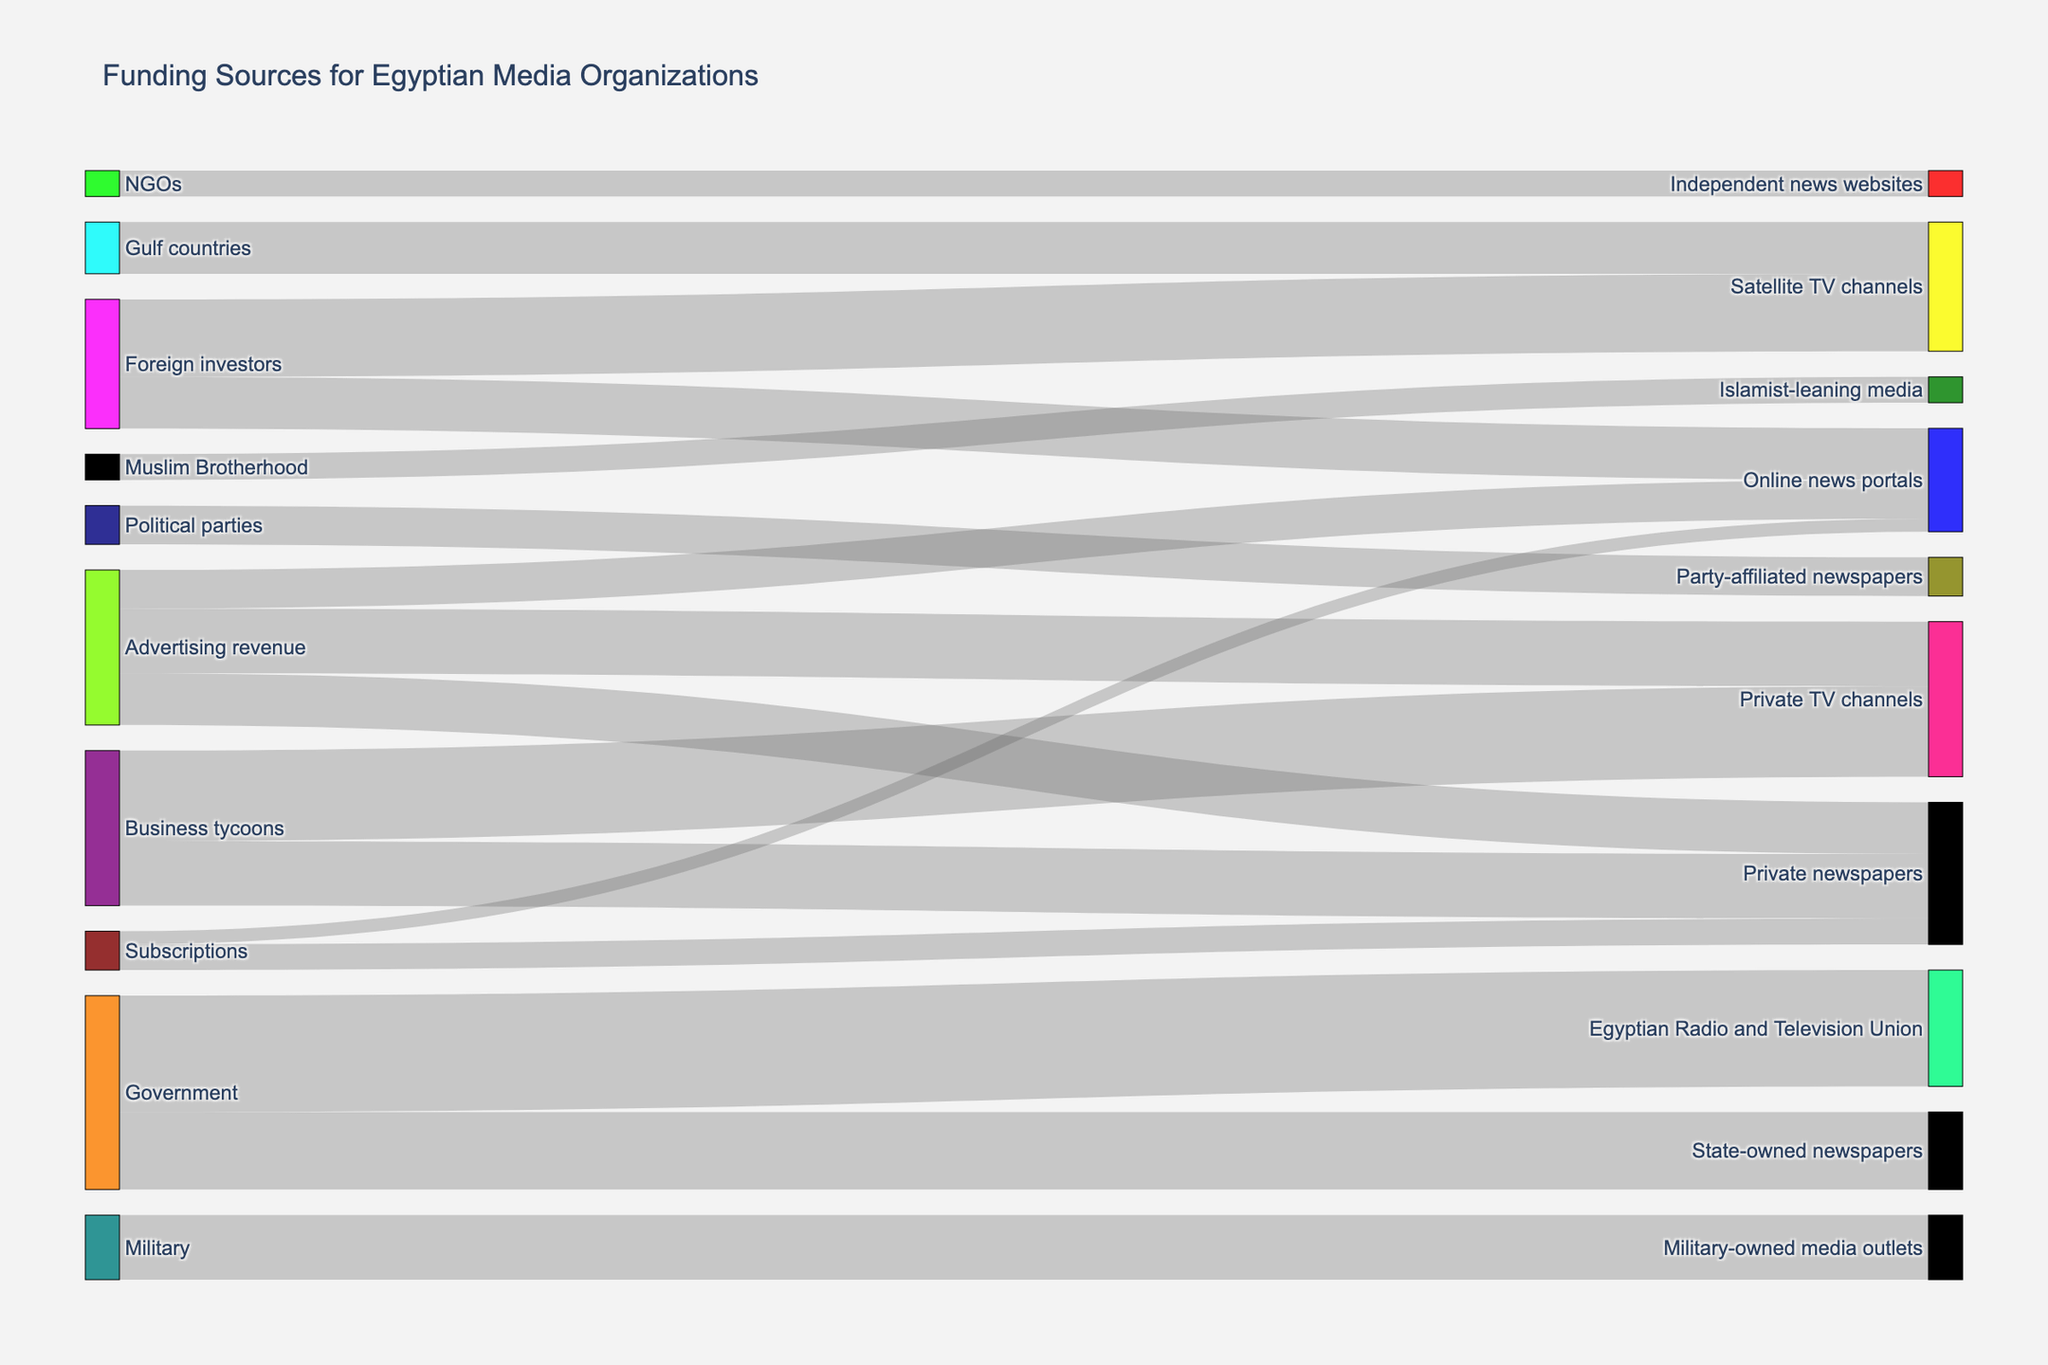what is the source contributing the most to state-owned newspapers? The figure shows the flow of funds from various sources to different media outlets. By tracing the largest flow that reaches state-owned newspapers, we see that the Government is the largest contributor with 30 units.
Answer: Government how many units of funding go to private TV channels? The figure indicates multiple flows reaching private TV channels. Summing up the units from both business tycoons (35) and advertising revenue (25), the total funding is 60 units.
Answer: 60 which funding sources contribute exactly 20 units to their respective targets? Examining each flow, we find that advertising revenue contributes 20 units to private newspapers, and foreign investors contribute 20 units to online news portals, and Gulf countries contribute 20 units to satellite TV channels.
Answer: advertising revenue, foreign investors, Gulf countries what is the combined funding from political parties and NGOs? Political parties contribute 15 units to party-affiliated newspapers, and NGOs contribute 10 units to independent news websites. Summing these up: 15 + 10 = 25 units.
Answer: 25 which target receives the highest number of unique sources? Observing the diagram, private newspapers receive from three different sources: business tycoons (25), advertising revenue (20), and subscriptions (10).
Answer: Private newspapers how does the funding for satellite TV channels compare between foreign investors and Gulf countries? The diagram indicates that foreign investors contribute 30 units, and Gulf countries contribute 20 units to satellite TV channels, making foreign investors the larger contributor.
Answer: Foreign investors contribute more which single category, among private TV channels and state-owned newspapers, relies more heavily on a non-governmental source? For state-owned newspapers, the sole source is the government, contributing 30 units. Private TV channels receive 35 units from business tycoons and 25 from advertising revenue, thus they rely more on non-governmental sources.
Answer: Private TV channels can you identify the source with the minimal individual contribution to any media outlet? By checking each funding flow, the minimal individual contribution is from NGOs to independent news websites, which is 10 units.
Answer: NGOs how much more funding does the Egyptian Radio and Television Union receive compared to the military-owned media outlets? The Egyptian Radio and Television Union receives 45 units from the government, while military-owned media outlets get 25 units from the military. The difference is 45 - 25 = 20 units.
Answer: 20 if advertising revenue was doubled, how much would private TV channels receive in total? Advertising revenue currently provides 25 units to private TV channels. Doubling this means 25 * 2 = 50 units. Adding the existing 35 units from business tycoons would result in 35 + 50 = 85 units.
Answer: 85 